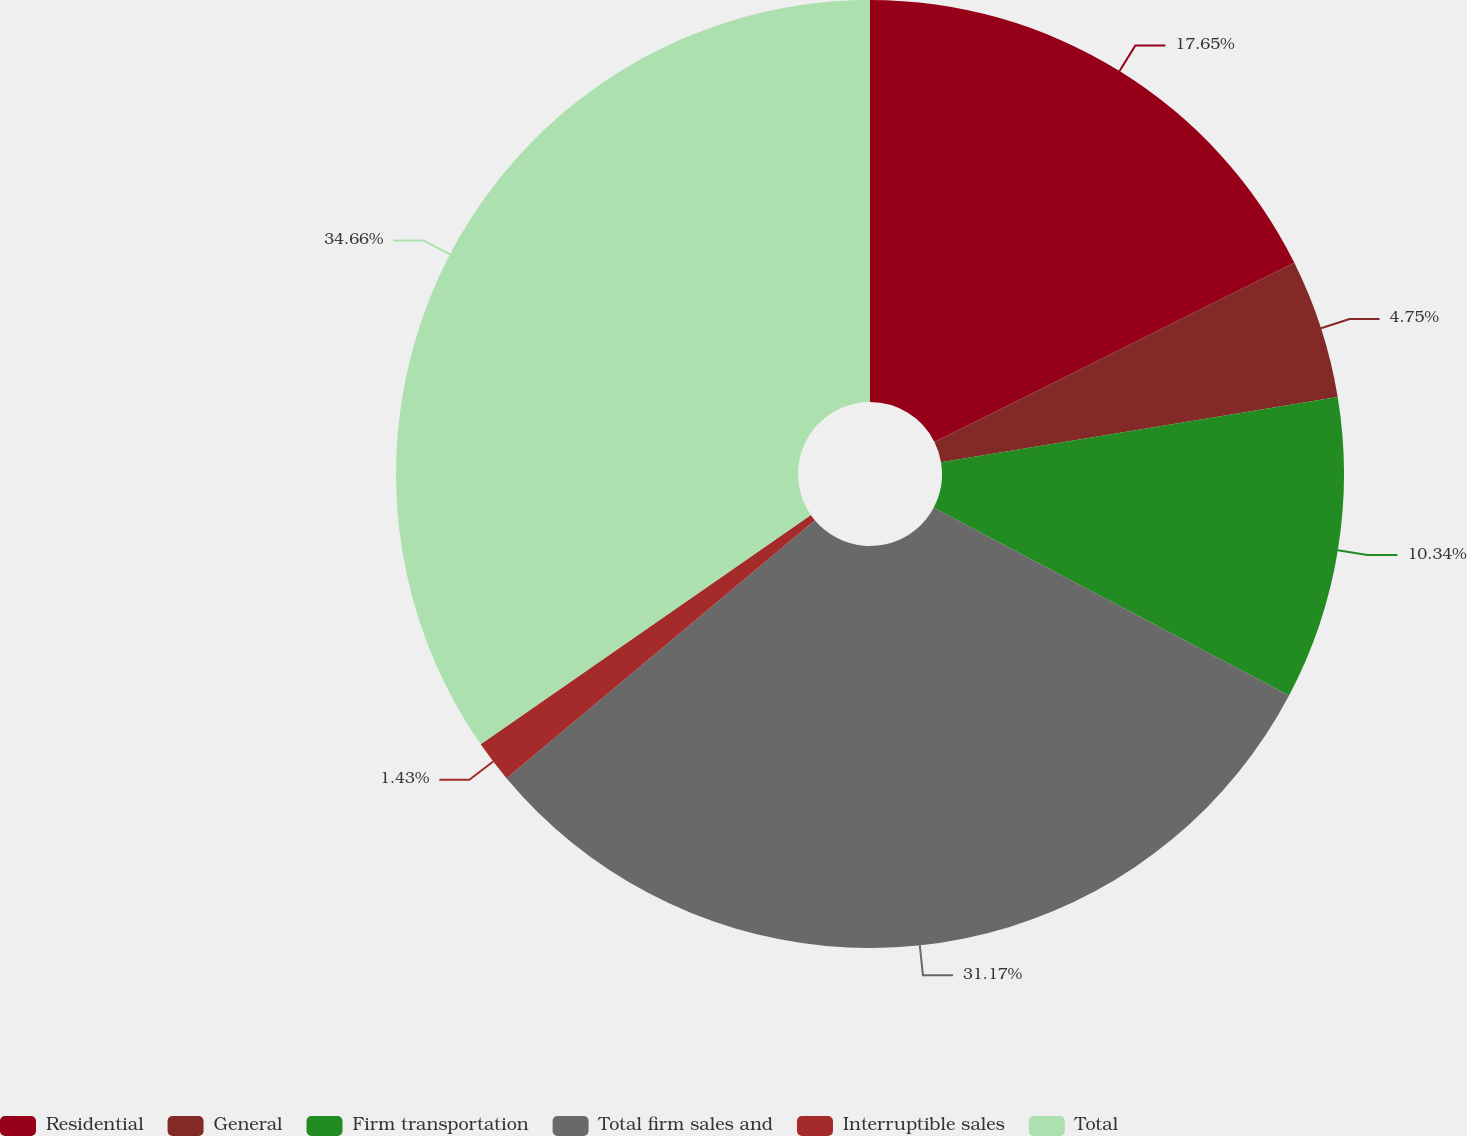Convert chart. <chart><loc_0><loc_0><loc_500><loc_500><pie_chart><fcel>Residential<fcel>General<fcel>Firm transportation<fcel>Total firm sales and<fcel>Interruptible sales<fcel>Total<nl><fcel>17.65%<fcel>4.75%<fcel>10.34%<fcel>31.17%<fcel>1.43%<fcel>34.66%<nl></chart> 